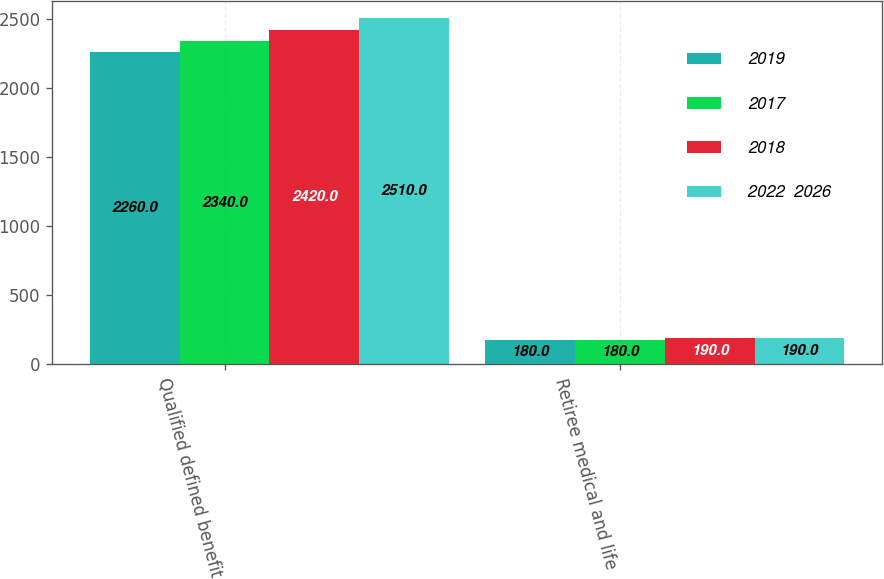<chart> <loc_0><loc_0><loc_500><loc_500><stacked_bar_chart><ecel><fcel>Qualified defined benefit<fcel>Retiree medical and life<nl><fcel>2019<fcel>2260<fcel>180<nl><fcel>2017<fcel>2340<fcel>180<nl><fcel>2018<fcel>2420<fcel>190<nl><fcel>2022  2026<fcel>2510<fcel>190<nl></chart> 